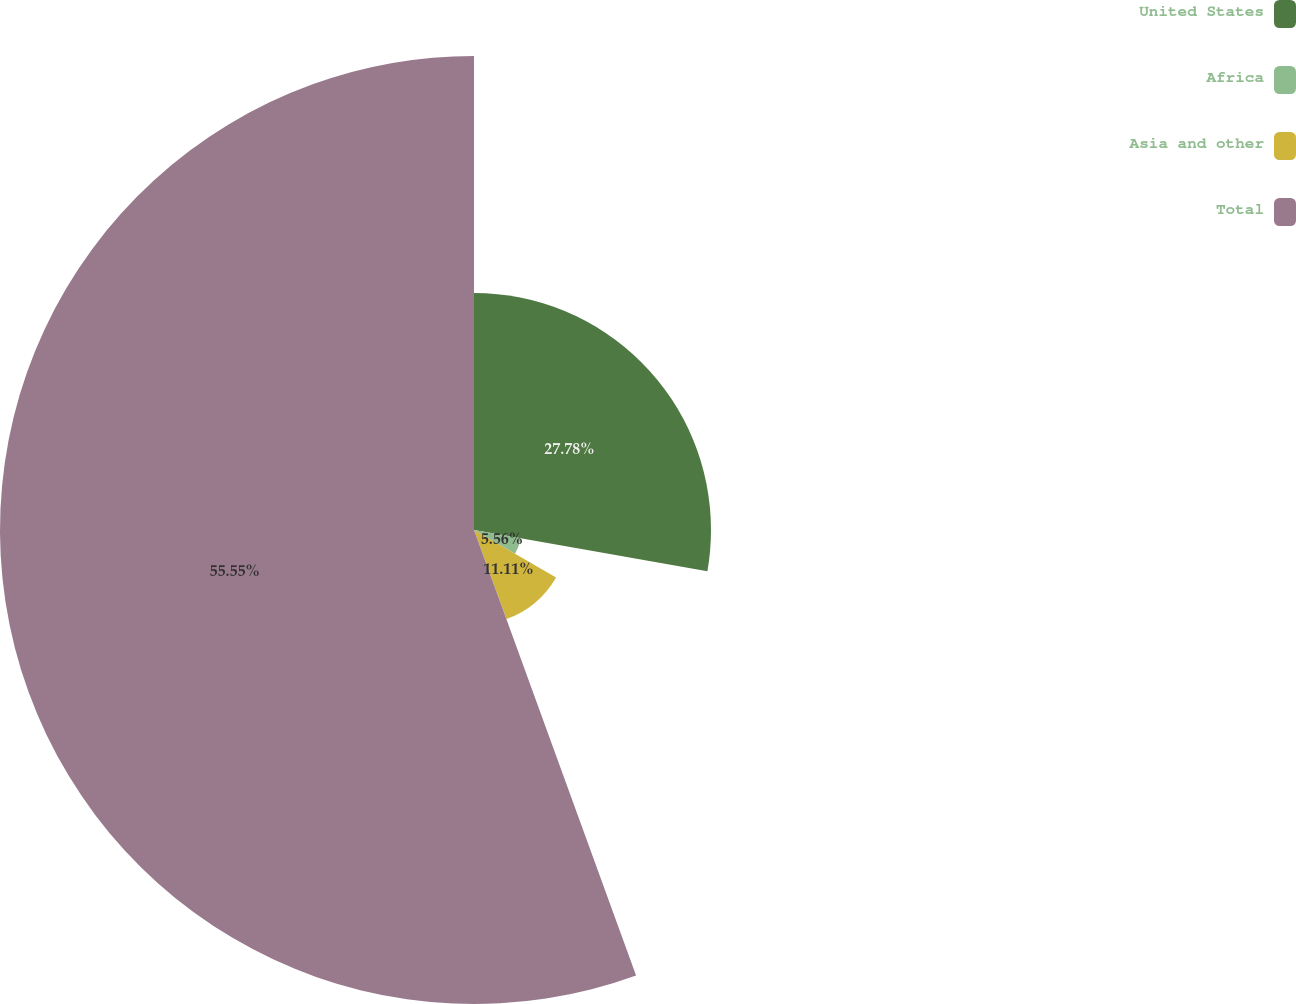Convert chart to OTSL. <chart><loc_0><loc_0><loc_500><loc_500><pie_chart><fcel>United States<fcel>Africa<fcel>Asia and other<fcel>Total<nl><fcel>27.78%<fcel>5.56%<fcel>11.11%<fcel>55.56%<nl></chart> 